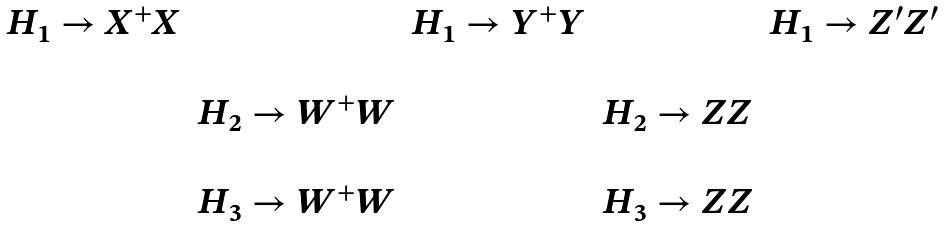Convert formula to latex. <formula><loc_0><loc_0><loc_500><loc_500>\begin{array} { c c c c c } H _ { 1 } \rightarrow X ^ { + } X & & H _ { 1 } \rightarrow Y ^ { + } Y & & H _ { 1 } \rightarrow Z ^ { \prime } Z ^ { \prime } \\ \\ & H _ { 2 } \rightarrow W ^ { + } W & & H _ { 2 } \rightarrow Z Z \\ \\ & H _ { 3 } \rightarrow W ^ { + } W & & H _ { 3 } \rightarrow Z Z \end{array}</formula> 